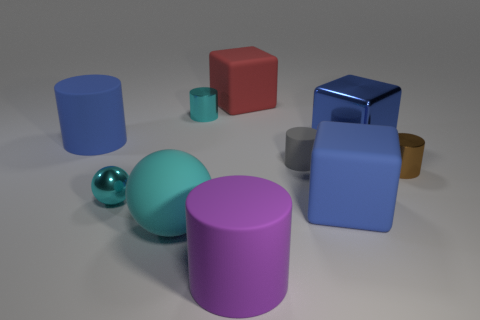There is a metal thing that is on the left side of the large red matte block and on the right side of the large cyan thing; what shape is it?
Your answer should be very brief. Cylinder. There is a big metallic object that is behind the large cyan matte thing; what shape is it?
Your answer should be compact. Cube. How many objects are both right of the large red rubber block and left of the purple matte object?
Offer a terse response. 0. There is a red rubber cube; is its size the same as the cylinder that is right of the tiny matte object?
Offer a terse response. No. How big is the sphere behind the big blue rubber object that is to the right of the large rubber block that is behind the large blue cylinder?
Provide a succinct answer. Small. How big is the blue cube that is behind the small brown shiny cylinder?
Your answer should be very brief. Large. The tiny gray thing that is made of the same material as the big blue cylinder is what shape?
Your answer should be very brief. Cylinder. Are the large cylinder that is behind the small shiny sphere and the small cyan cylinder made of the same material?
Your answer should be compact. No. How many other objects are there of the same material as the purple object?
Your answer should be very brief. 5. What number of objects are objects in front of the red matte block or small metal cylinders right of the small gray rubber object?
Offer a very short reply. 9. 